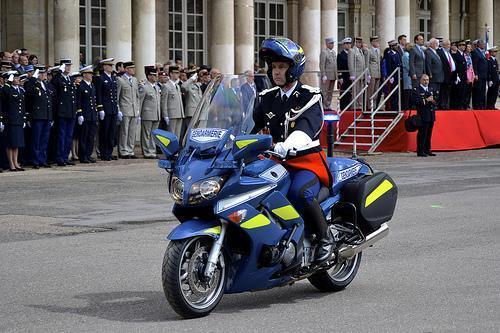How many motorcycles are shown?
Give a very brief answer. 1. How many wheels are shown?
Give a very brief answer. 2. 